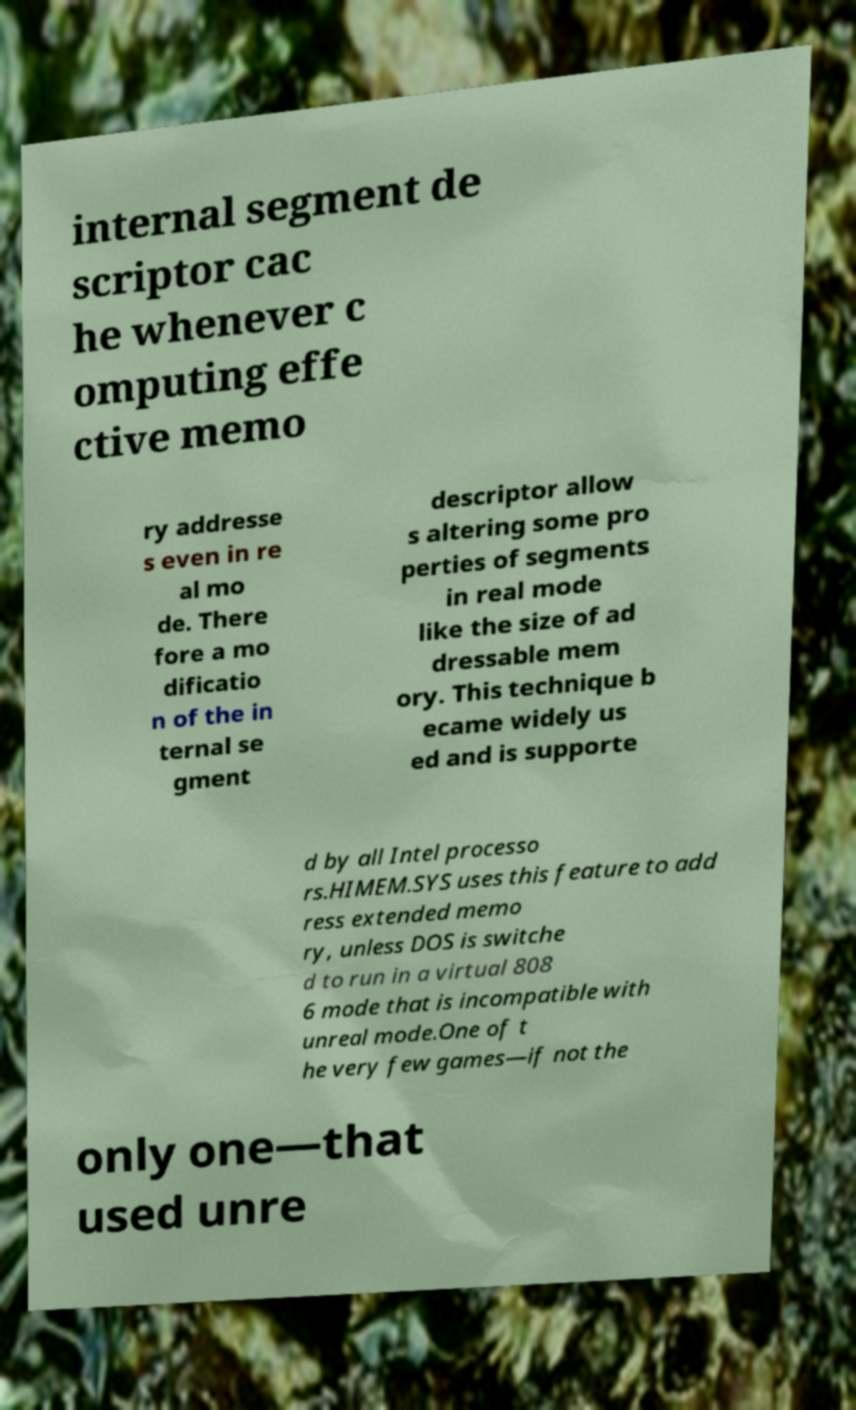What messages or text are displayed in this image? I need them in a readable, typed format. internal segment de scriptor cac he whenever c omputing effe ctive memo ry addresse s even in re al mo de. There fore a mo dificatio n of the in ternal se gment descriptor allow s altering some pro perties of segments in real mode like the size of ad dressable mem ory. This technique b ecame widely us ed and is supporte d by all Intel processo rs.HIMEM.SYS uses this feature to add ress extended memo ry, unless DOS is switche d to run in a virtual 808 6 mode that is incompatible with unreal mode.One of t he very few games—if not the only one—that used unre 